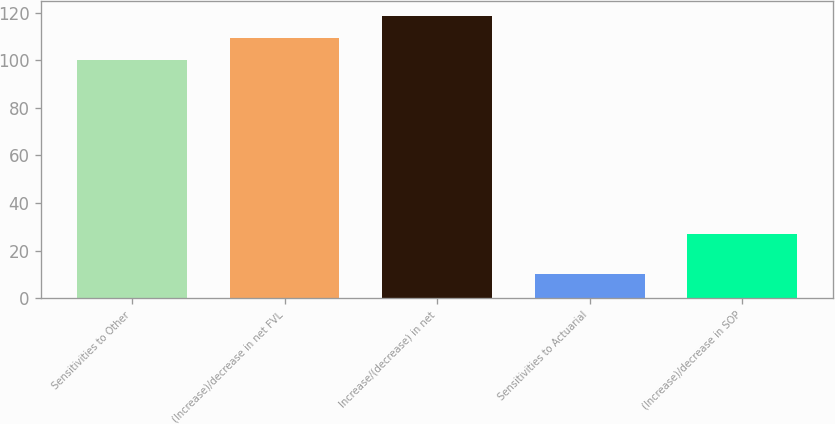Convert chart. <chart><loc_0><loc_0><loc_500><loc_500><bar_chart><fcel>Sensitivities to Other<fcel>(Increase)/decrease in net FVL<fcel>Increase/(decrease) in net<fcel>Sensitivities to Actuarial<fcel>(Increase)/decrease in SOP<nl><fcel>100<fcel>109.4<fcel>118.8<fcel>10<fcel>27<nl></chart> 